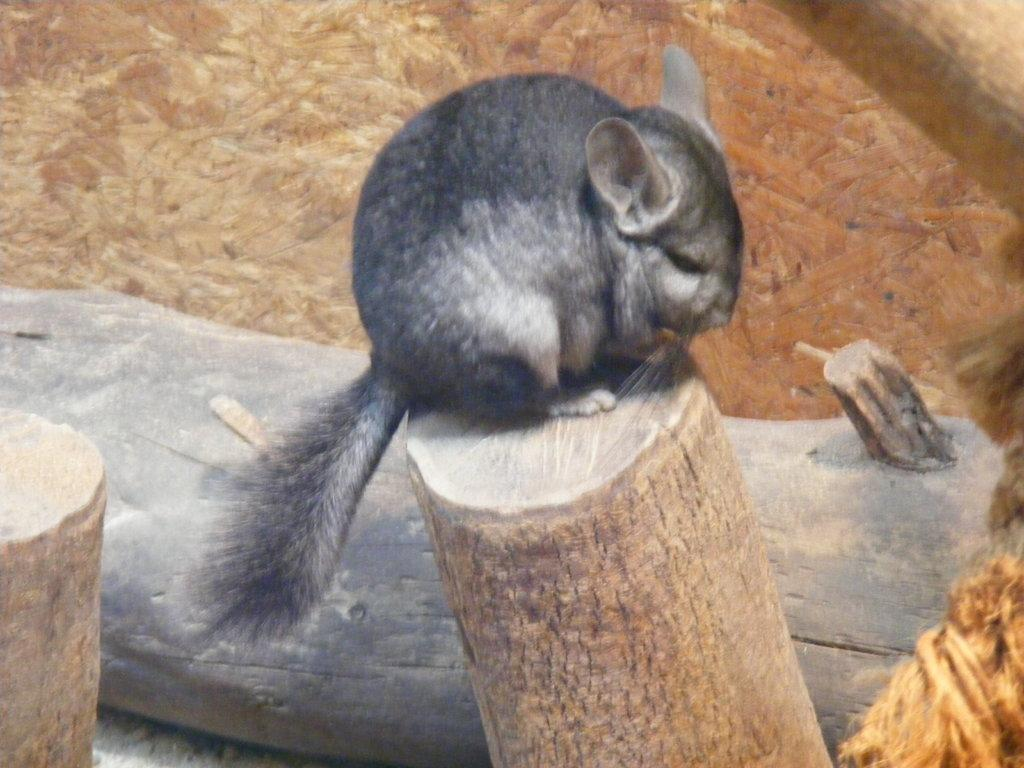What type of animal is in the image? There is a chinchilla in the image. Where is the chinchilla located? The chinchilla is on a trunk. What else can be seen in the background of the image? There are more trunks visible in the background of the image. What color is the crayon being used by the chinchilla in the image? There is no crayon present in the image, and the chinchilla is not using any crayons. 